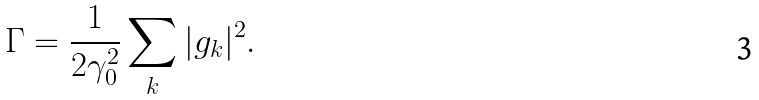Convert formula to latex. <formula><loc_0><loc_0><loc_500><loc_500>\Gamma = \frac { 1 } { 2 \gamma _ { 0 } ^ { 2 } } \sum _ { k } | g _ { k } | ^ { 2 } .</formula> 